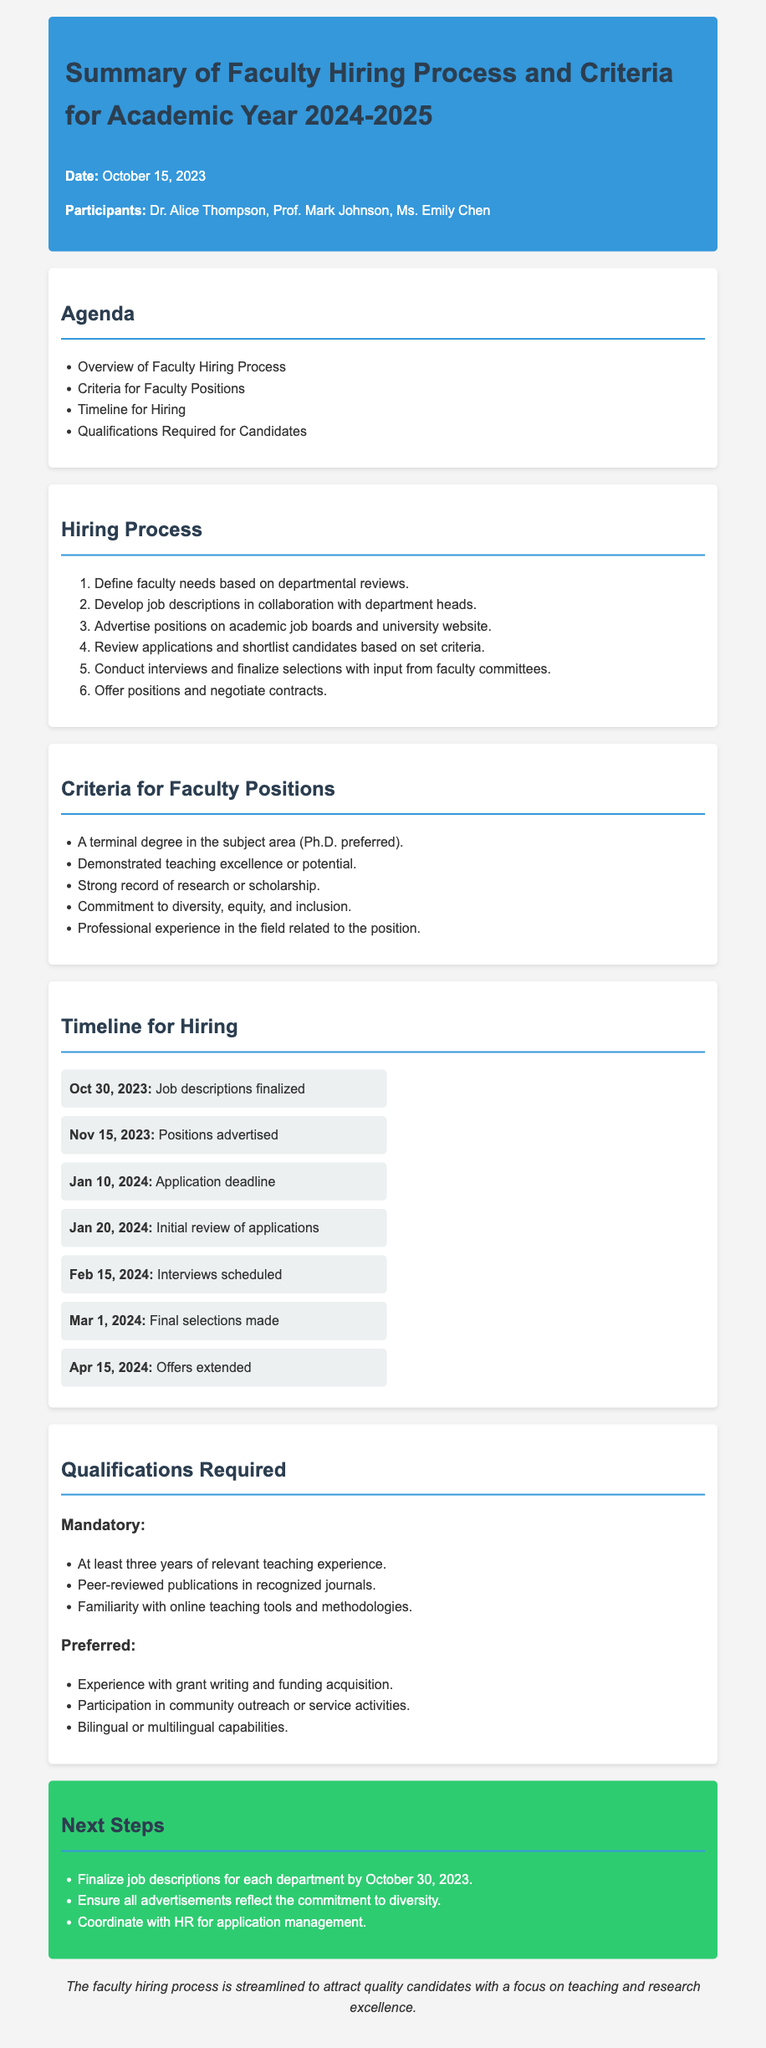What is the date of the meeting? The date of the meeting is stated at the beginning of the minutes as October 15, 2023.
Answer: October 15, 2023 Who were the participants in the meeting? The participants of the meeting are listed under the header, which includes Dr. Alice Thompson, Prof. Mark Johnson, and Ms. Emily Chen.
Answer: Dr. Alice Thompson, Prof. Mark Johnson, Ms. Emily Chen What is the application deadline? The application deadline is specified in the timeline section as January 10, 2024.
Answer: January 10, 2024 What is one mandatory qualification required for candidates? A specific qualification is listed in the qualifications section, and one of them is at least three years of relevant teaching experience.
Answer: At least three years of relevant teaching experience What is the focus of the faculty hiring process? The closing remark summarizes the hiring process's goal, which is to attract quality candidates with a focus on teaching and research excellence.
Answer: Teaching and research excellence What is the timeline item for final selections? The timeline item for final selections indicates when the final decisions will be made regarding candidates, which is March 1, 2024.
Answer: March 1, 2024 What is a preferred qualification listed for candidates? A preferred qualification is mentioned, such as experience with grant writing and funding acquisition, which is part of the 'Preferred' section.
Answer: Experience with grant writing and funding acquisition Which section details the hiring process? The hiring process is outlined in a dedicated section titled "Hiring Process," where steps are listed in an ordered format.
Answer: Hiring Process What is the next step after finalizing job descriptions? The document discusses next steps, and one of them is ensuring all advertisements reflect the commitment to diversity.
Answer: Ensure all advertisements reflect the commitment to diversity 